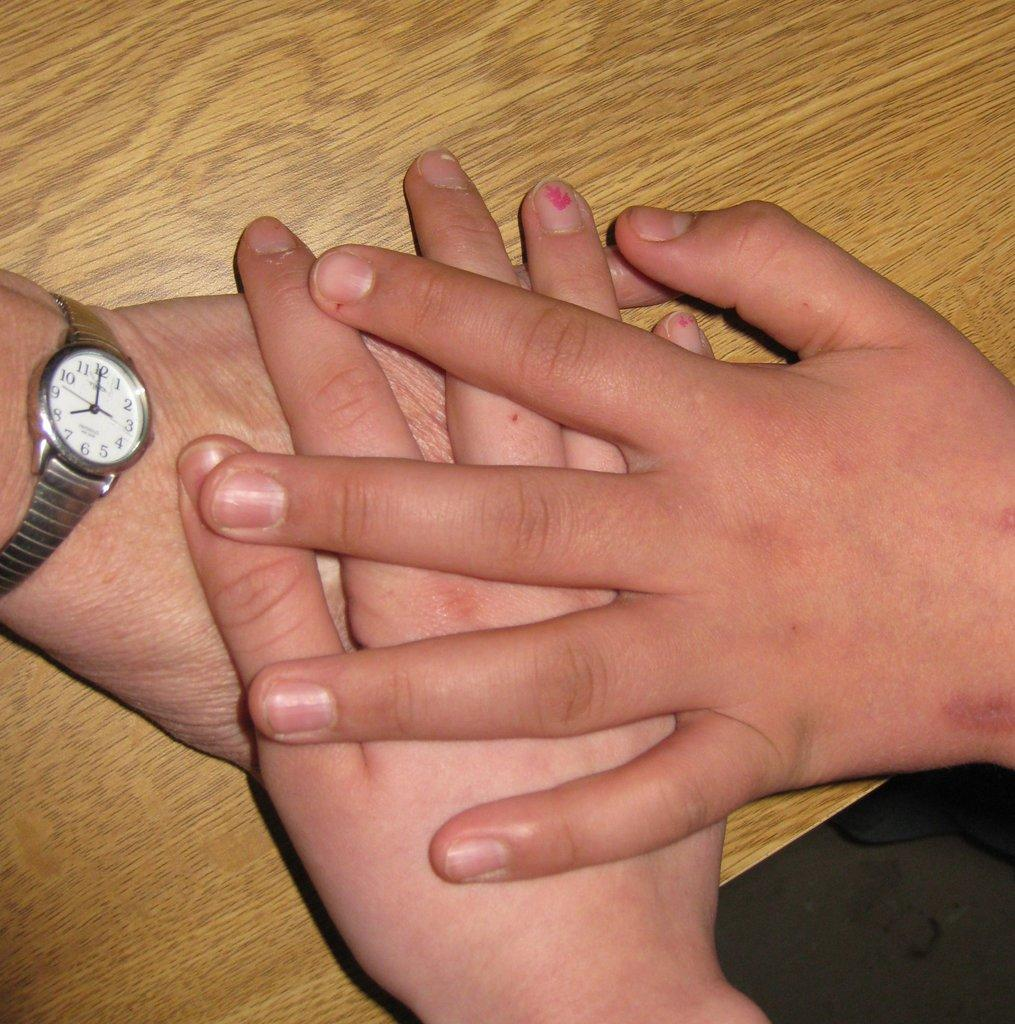<image>
Relay a brief, clear account of the picture shown. Three hands placed on top of each other including the one with a wrist watch showing 8 o'clock. 